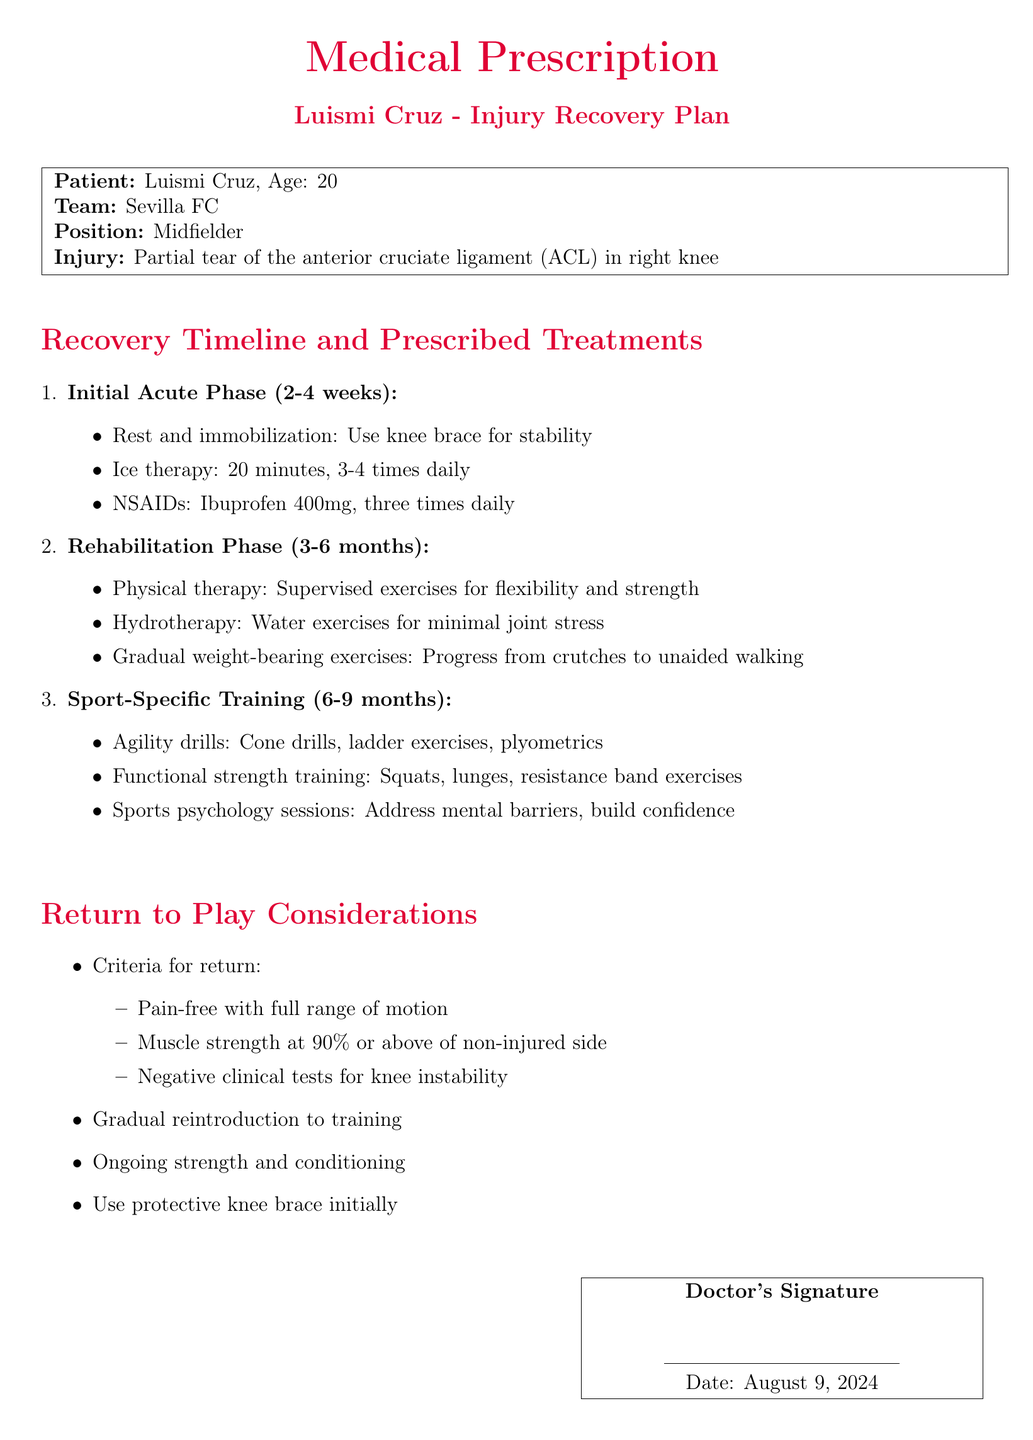What is Luismi Cruz's age? The document specifies Luismi Cruz's age as indicated in the patient details.
Answer: 20 What is the injury type mentioned? The document clearly states the injury type in the patient's details section.
Answer: Partial tear of the anterior cruciate ligament (ACL) How long is the initial acute phase? The timeline indicates the duration of the initial phase as specified in the recovery timeline section.
Answer: 2-4 weeks What is one prescribed treatment in the initial acute phase? The treatment recommendations are outlined in the initial acute phase section.
Answer: Ice therapy What criteria must be met for return to play? The document lists multiple criteria for return; a specific query will point out one of them.
Answer: Pain-free with full range of motion What exercises are included in the sport-specific training? The rehabilitation section details specific training exercises, and this question asks for one item from that list.
Answer: Agility drills What is the initial recommendation for knee support during training? The return to play considerations mention safety equipment that should be used initially.
Answer: Protective knee brace What type of therapy is mentioned during the rehabilitation phase? The rehabilitation phase includes details about types of therapy as outlined in the document.
Answer: Physical therapy What is the recommended dosage of Ibuprofen? The document details the dosage of pain-relief medication in the initial acute phase.
Answer: 400mg, three times daily 